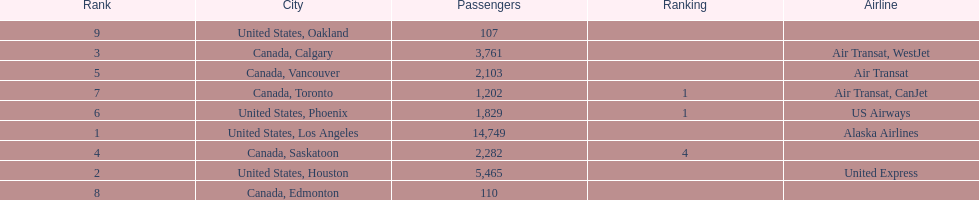Los angeles and what other city had about 19,000 passenger combined Canada, Calgary. 